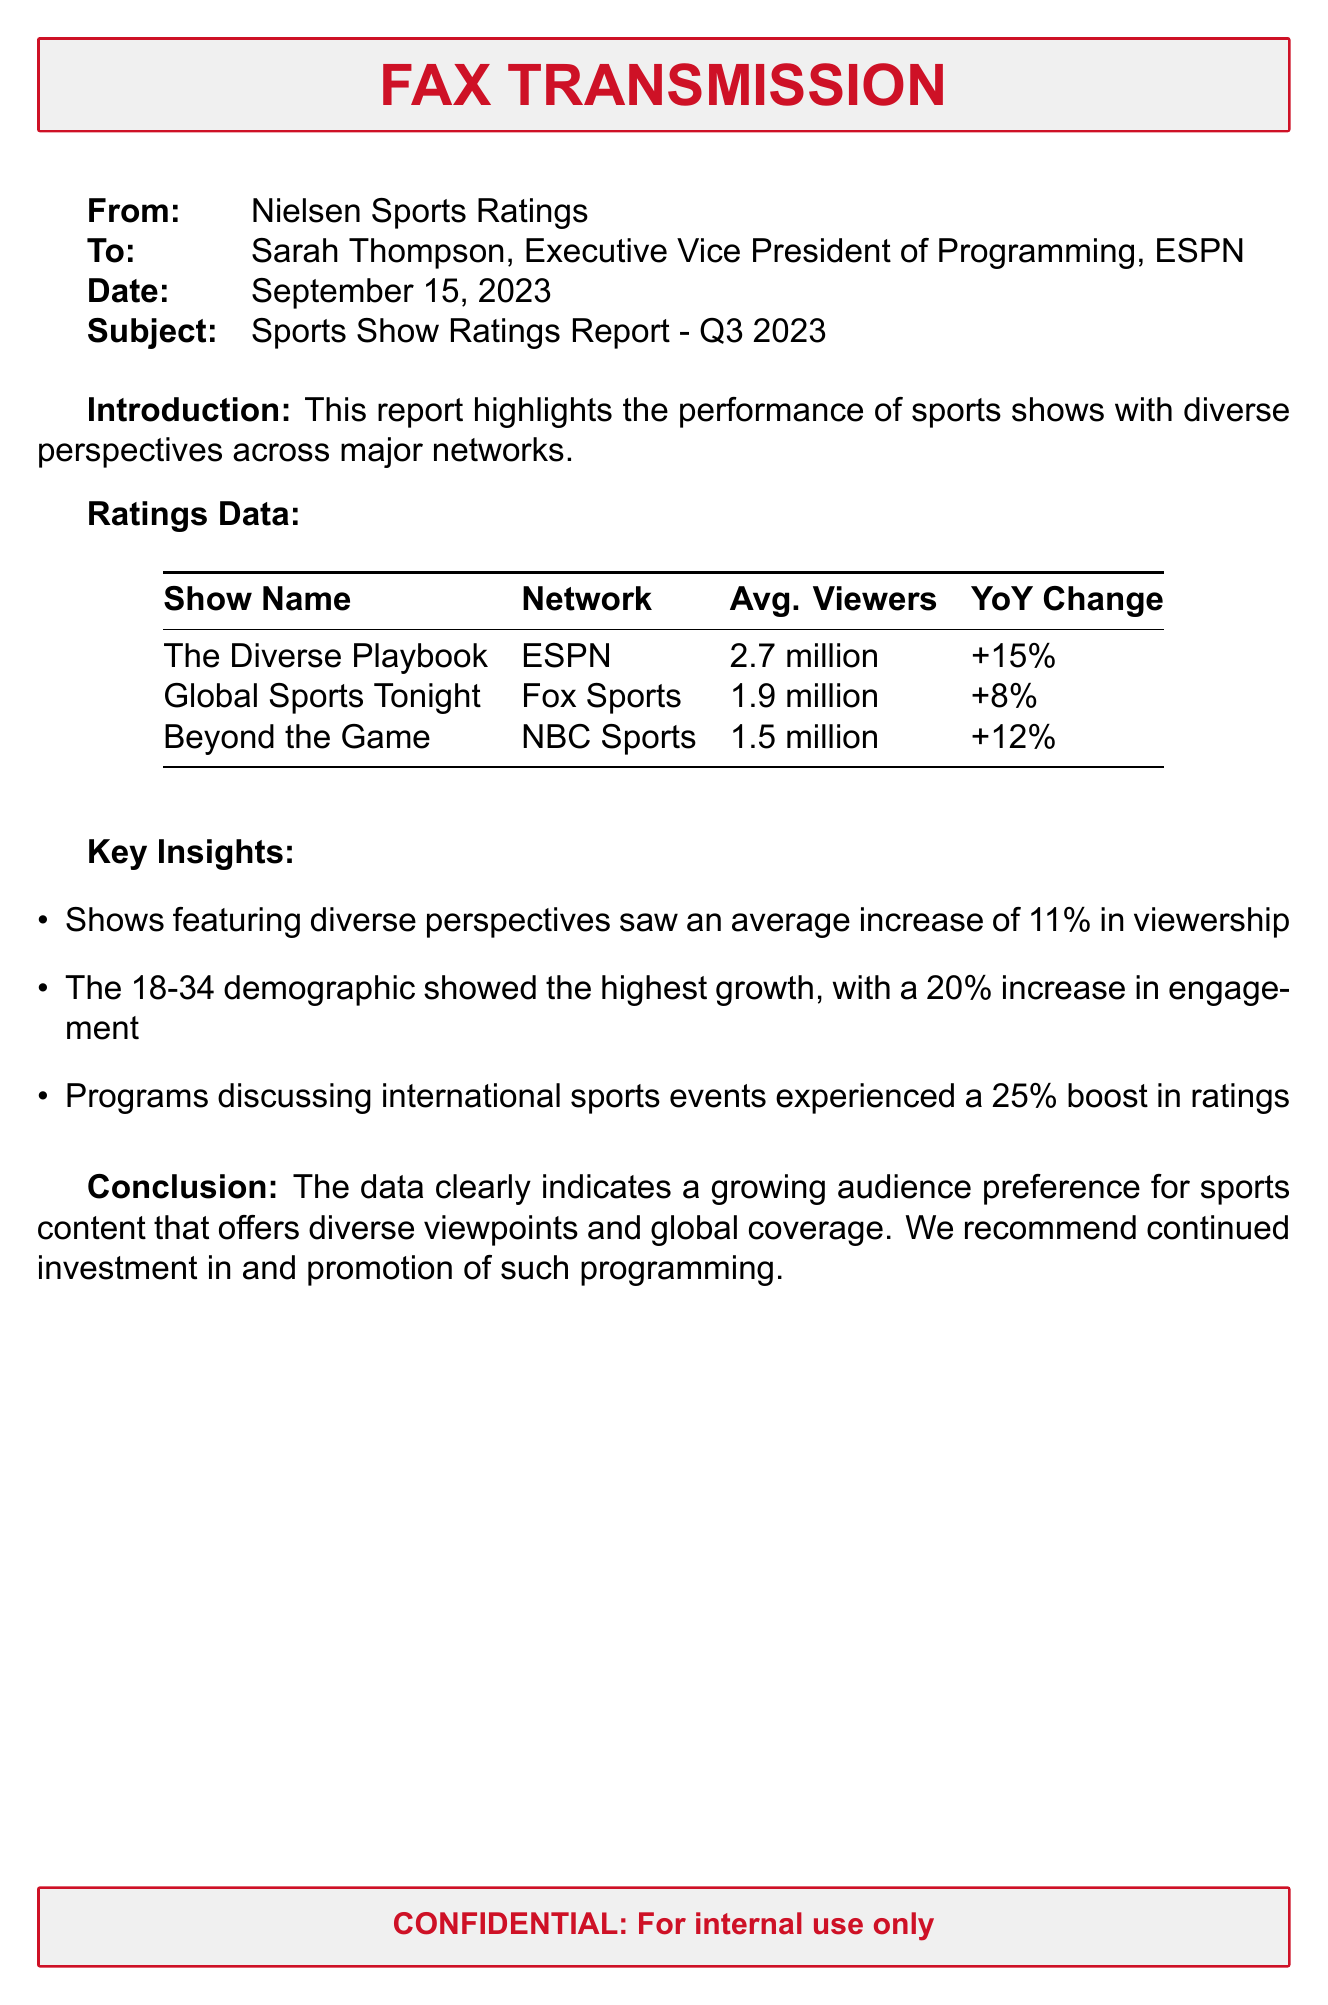what is the average viewership for The Diverse Playbook? The average viewership for The Diverse Playbook is provided in the ratings data section of the document, which states it has 2.7 million viewers.
Answer: 2.7 million what was the year-over-year change for Global Sports Tonight? The year-over-year change for Global Sports Tonight is indicated in the ratings data section, which shows an increase of 8%.
Answer: +8% which demographic showed the highest growth? The document mentions the 18-34 demographic as the one showing the highest growth in engagement.
Answer: 18-34 what was the average increase in viewership for shows featuring diverse perspectives? The key insights section of the document states that shows with diverse perspectives saw an average increase of 11% in viewership.
Answer: 11% how many viewers did Beyond the Game attract? The ratings data section includes a figure for Beyond the Game, which attracted 1.5 million viewers.
Answer: 1.5 million which program experienced a 25% boost in ratings? The document implies that programs discussing international sports events saw this boost, which is a key insight mentioned.
Answer: Programs discussing international sports events who is the recipient of this fax? The fax clearly states that the recipient is Sarah Thompson, Executive Vice President of Programming at ESPN.
Answer: Sarah Thompson what is the date of this transmission? The date of transmission is specified in the header of the fax as September 15, 2023.
Answer: September 15, 2023 what is the subject of this fax? The subject line of the fax identifies the topic as "Sports Show Ratings Report - Q3 2023."
Answer: Sports Show Ratings Report - Q3 2023 